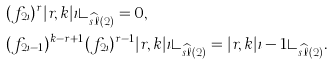<formula> <loc_0><loc_0><loc_500><loc_500>& ( f _ { 2 \iota } ) ^ { r } | r , k | \iota \rangle _ { \widehat { s \ell } ( 2 ) } = 0 , \\ & ( f _ { 2 \iota - 1 } ) ^ { k - r + 1 } ( f _ { 2 \iota } ) ^ { r - 1 } | r , k | \iota \rangle _ { \widehat { s \ell } ( 2 ) } = | r , k | \iota - 1 \rangle _ { \widehat { s \ell } ( 2 ) } .</formula> 